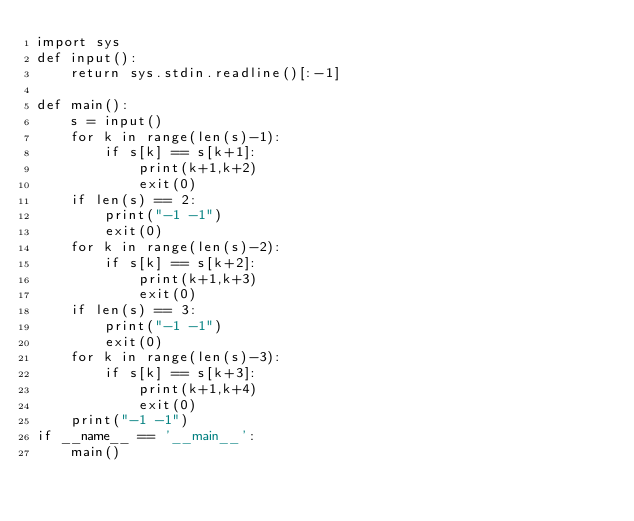<code> <loc_0><loc_0><loc_500><loc_500><_Python_>import sys
def input():
    return sys.stdin.readline()[:-1]

def main():
    s = input()
    for k in range(len(s)-1):
        if s[k] == s[k+1]:
            print(k+1,k+2)
            exit(0)
    if len(s) == 2:
        print("-1 -1")
        exit(0)
    for k in range(len(s)-2):
        if s[k] == s[k+2]:
            print(k+1,k+3)
            exit(0)
    if len(s) == 3:
        print("-1 -1")
        exit(0)
    for k in range(len(s)-3):
        if s[k] == s[k+3]:
            print(k+1,k+4)
            exit(0)
    print("-1 -1")
if __name__ == '__main__':
    main()
</code> 